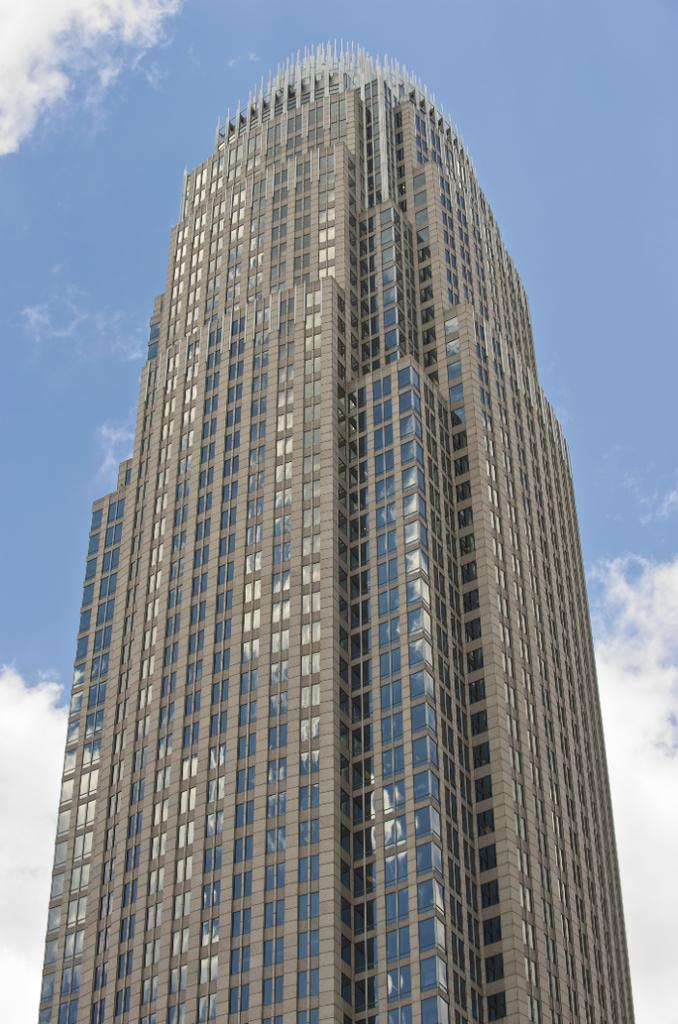What is the main subject in the center of the image? There is a building in the center of the image. What can be seen at the top of the image? The sky is visible at the top of the image. What type of tramp is performing a show in the background of the image? There is no tramp or show present in the image; it only features a building and the sky. 